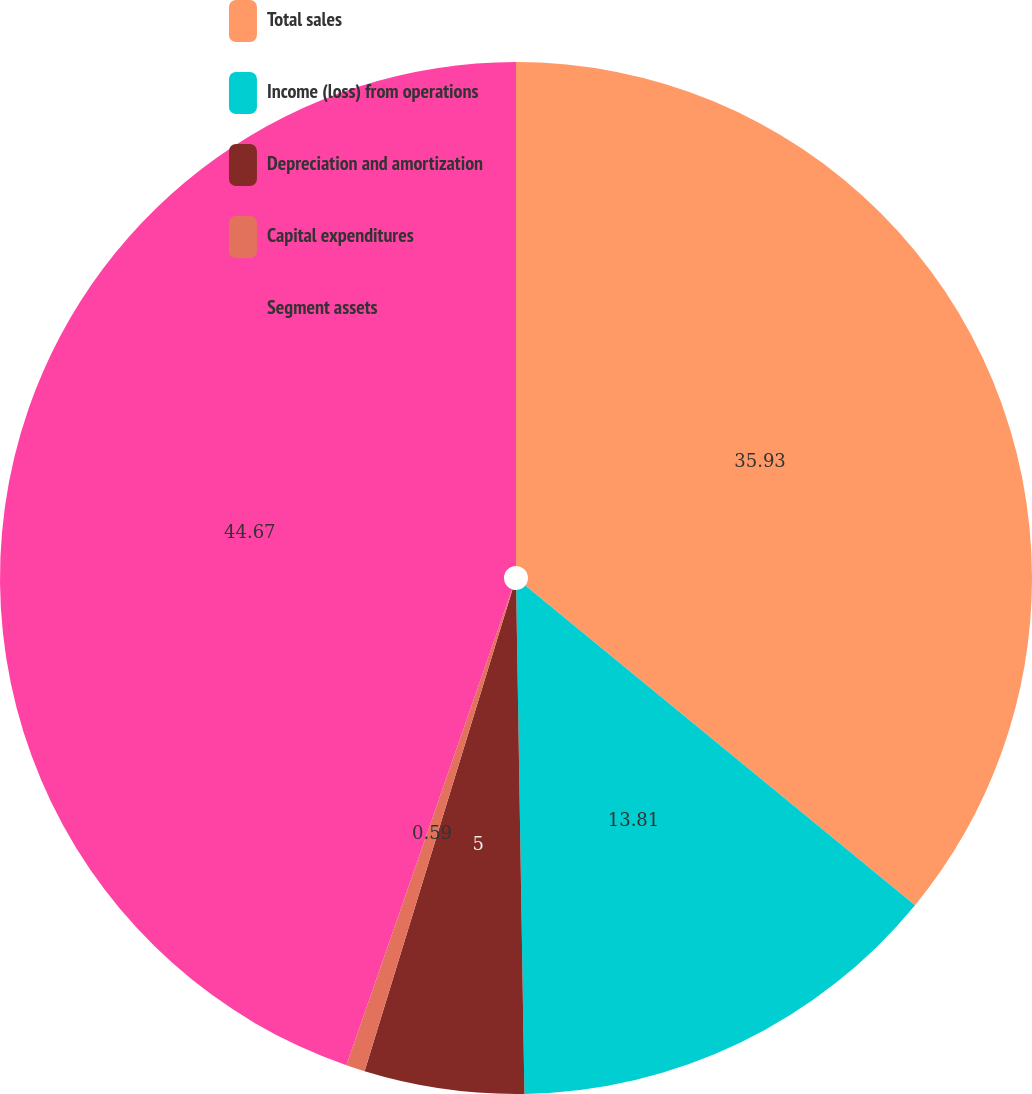<chart> <loc_0><loc_0><loc_500><loc_500><pie_chart><fcel>Total sales<fcel>Income (loss) from operations<fcel>Depreciation and amortization<fcel>Capital expenditures<fcel>Segment assets<nl><fcel>35.93%<fcel>13.81%<fcel>5.0%<fcel>0.59%<fcel>44.67%<nl></chart> 